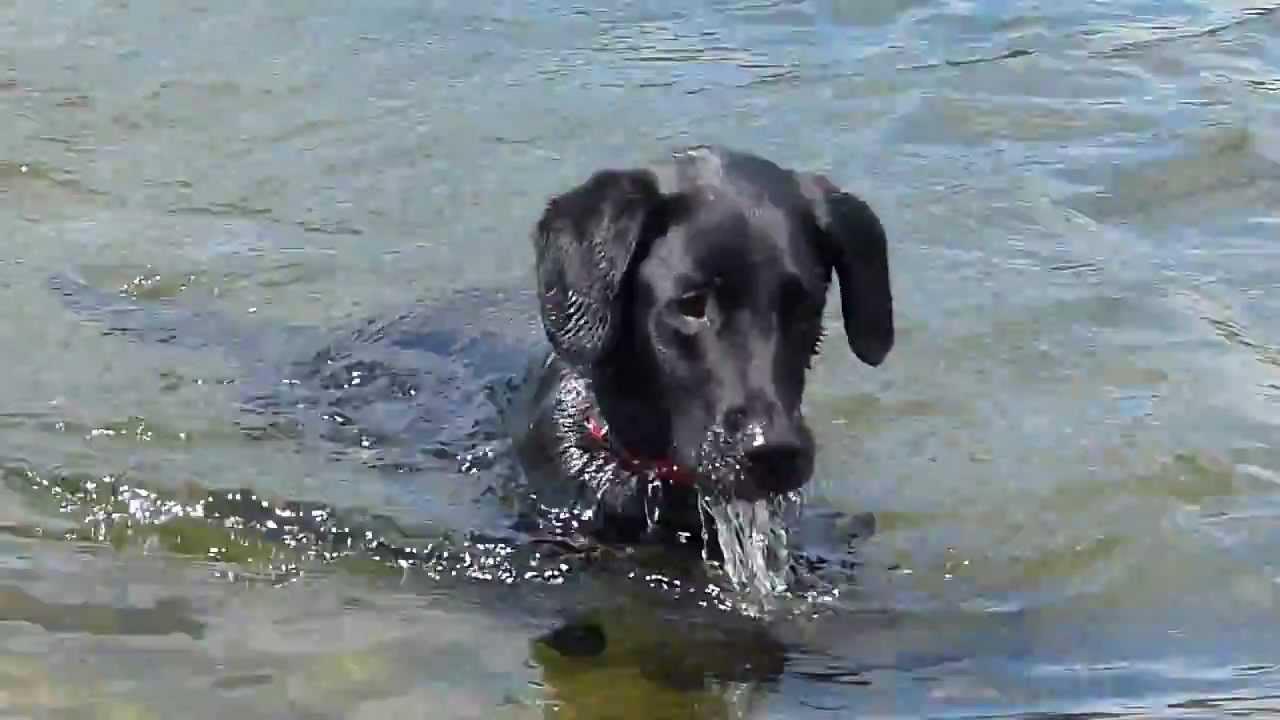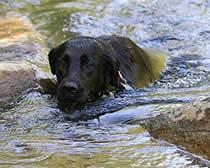The first image is the image on the left, the second image is the image on the right. Given the left and right images, does the statement "At least one dog has it's tail out of the water." hold true? Answer yes or no. No. The first image is the image on the left, the second image is the image on the right. Analyze the images presented: Is the assertion "In one image the dog is facing forward, and in the other it is facing to the side." valid? Answer yes or no. No. 